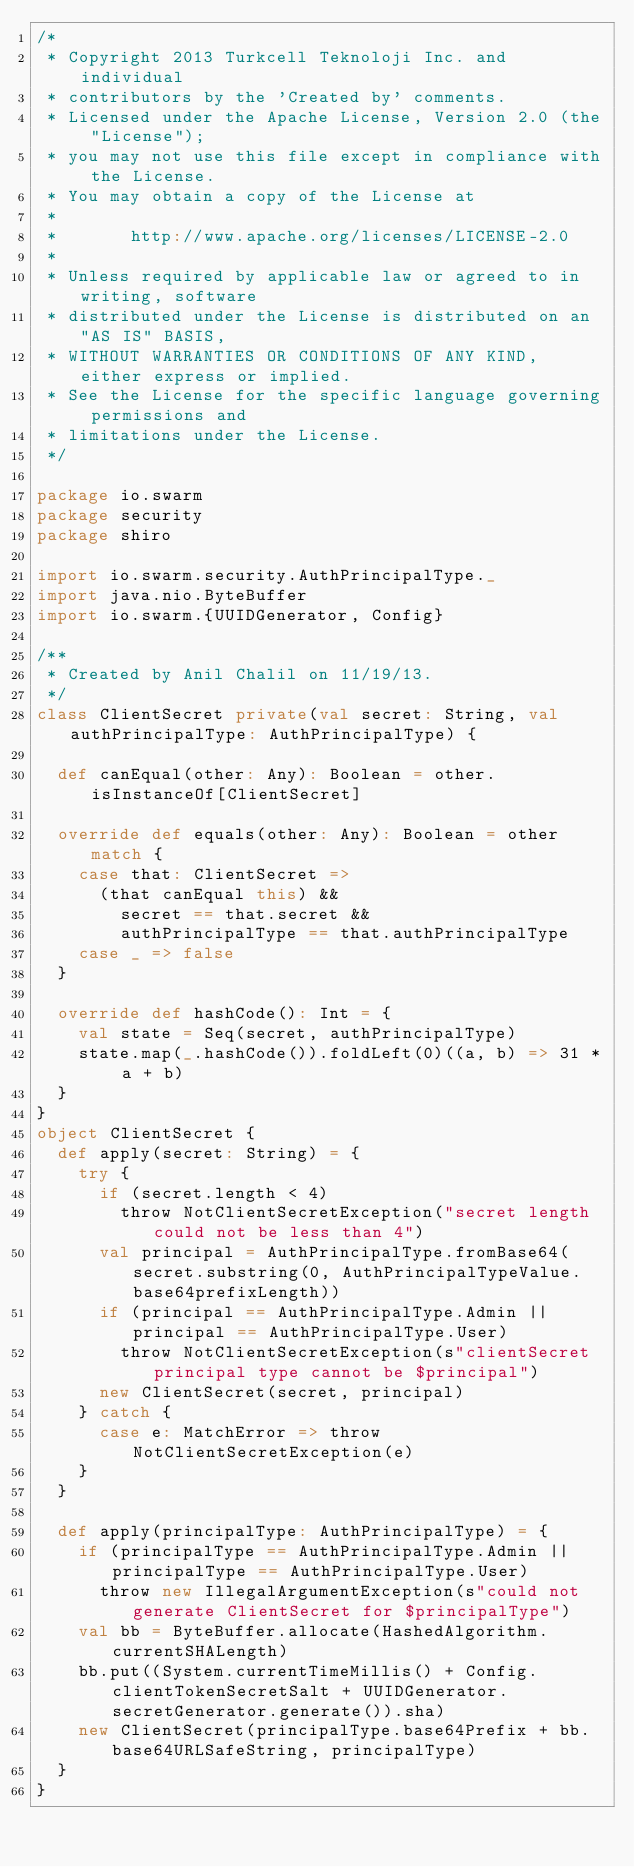Convert code to text. <code><loc_0><loc_0><loc_500><loc_500><_Scala_>/*
 * Copyright 2013 Turkcell Teknoloji Inc. and individual
 * contributors by the 'Created by' comments.
 * Licensed under the Apache License, Version 2.0 (the "License");
 * you may not use this file except in compliance with the License.
 * You may obtain a copy of the License at
 *
 *       http://www.apache.org/licenses/LICENSE-2.0
 *
 * Unless required by applicable law or agreed to in writing, software
 * distributed under the License is distributed on an "AS IS" BASIS,
 * WITHOUT WARRANTIES OR CONDITIONS OF ANY KIND, either express or implied.
 * See the License for the specific language governing permissions and
 * limitations under the License.
 */

package io.swarm
package security
package shiro

import io.swarm.security.AuthPrincipalType._
import java.nio.ByteBuffer
import io.swarm.{UUIDGenerator, Config}

/**
 * Created by Anil Chalil on 11/19/13.
 */
class ClientSecret private(val secret: String, val authPrincipalType: AuthPrincipalType) {

  def canEqual(other: Any): Boolean = other.isInstanceOf[ClientSecret]

  override def equals(other: Any): Boolean = other match {
    case that: ClientSecret =>
      (that canEqual this) &&
        secret == that.secret &&
        authPrincipalType == that.authPrincipalType
    case _ => false
  }

  override def hashCode(): Int = {
    val state = Seq(secret, authPrincipalType)
    state.map(_.hashCode()).foldLeft(0)((a, b) => 31 * a + b)
  }
}
object ClientSecret {
  def apply(secret: String) = {
    try {
      if (secret.length < 4)
        throw NotClientSecretException("secret length could not be less than 4")
      val principal = AuthPrincipalType.fromBase64(secret.substring(0, AuthPrincipalTypeValue.base64prefixLength))
      if (principal == AuthPrincipalType.Admin || principal == AuthPrincipalType.User)
        throw NotClientSecretException(s"clientSecret principal type cannot be $principal")
      new ClientSecret(secret, principal)
    } catch {
      case e: MatchError => throw NotClientSecretException(e)
    }
  }

  def apply(principalType: AuthPrincipalType) = {
    if (principalType == AuthPrincipalType.Admin || principalType == AuthPrincipalType.User)
      throw new IllegalArgumentException(s"could not generate ClientSecret for $principalType")
    val bb = ByteBuffer.allocate(HashedAlgorithm.currentSHALength)
    bb.put((System.currentTimeMillis() + Config.clientTokenSecretSalt + UUIDGenerator.secretGenerator.generate()).sha)
    new ClientSecret(principalType.base64Prefix + bb.base64URLSafeString, principalType)
  }
}
</code> 